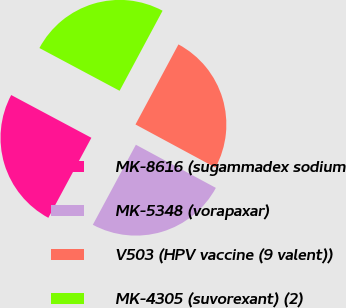Convert chart. <chart><loc_0><loc_0><loc_500><loc_500><pie_chart><fcel>MK-8616 (sugammadex sodium<fcel>MK-5348 (vorapaxar)<fcel>V503 (HPV vaccine (9 valent))<fcel>MK-4305 (suvorexant) (2)<nl><fcel>24.94%<fcel>24.98%<fcel>25.03%<fcel>25.04%<nl></chart> 